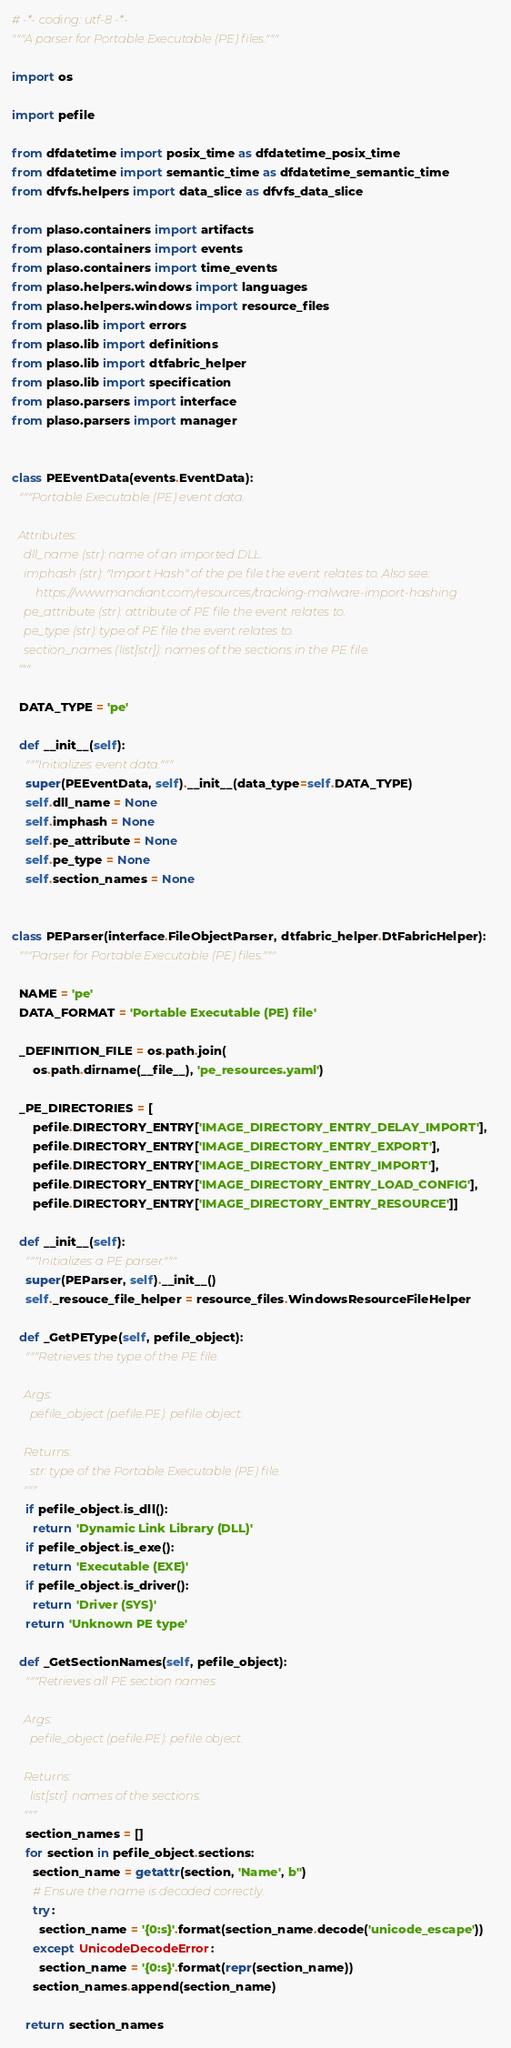Convert code to text. <code><loc_0><loc_0><loc_500><loc_500><_Python_># -*- coding: utf-8 -*-
"""A parser for Portable Executable (PE) files."""

import os

import pefile

from dfdatetime import posix_time as dfdatetime_posix_time
from dfdatetime import semantic_time as dfdatetime_semantic_time
from dfvfs.helpers import data_slice as dfvfs_data_slice

from plaso.containers import artifacts
from plaso.containers import events
from plaso.containers import time_events
from plaso.helpers.windows import languages
from plaso.helpers.windows import resource_files
from plaso.lib import errors
from plaso.lib import definitions
from plaso.lib import dtfabric_helper
from plaso.lib import specification
from plaso.parsers import interface
from plaso.parsers import manager


class PEEventData(events.EventData):
  """Portable Executable (PE) event data.

  Attributes:
    dll_name (str): name of an imported DLL.
    imphash (str): "Import Hash" of the pe file the event relates to. Also see:
        https://www.mandiant.com/resources/tracking-malware-import-hashing
    pe_attribute (str): attribute of PE file the event relates to.
    pe_type (str): type of PE file the event relates to.
    section_names (list[str]): names of the sections in the PE file.
  """

  DATA_TYPE = 'pe'

  def __init__(self):
    """Initializes event data."""
    super(PEEventData, self).__init__(data_type=self.DATA_TYPE)
    self.dll_name = None
    self.imphash = None
    self.pe_attribute = None
    self.pe_type = None
    self.section_names = None


class PEParser(interface.FileObjectParser, dtfabric_helper.DtFabricHelper):
  """Parser for Portable Executable (PE) files."""

  NAME = 'pe'
  DATA_FORMAT = 'Portable Executable (PE) file'

  _DEFINITION_FILE = os.path.join(
      os.path.dirname(__file__), 'pe_resources.yaml')

  _PE_DIRECTORIES = [
      pefile.DIRECTORY_ENTRY['IMAGE_DIRECTORY_ENTRY_DELAY_IMPORT'],
      pefile.DIRECTORY_ENTRY['IMAGE_DIRECTORY_ENTRY_EXPORT'],
      pefile.DIRECTORY_ENTRY['IMAGE_DIRECTORY_ENTRY_IMPORT'],
      pefile.DIRECTORY_ENTRY['IMAGE_DIRECTORY_ENTRY_LOAD_CONFIG'],
      pefile.DIRECTORY_ENTRY['IMAGE_DIRECTORY_ENTRY_RESOURCE']]

  def __init__(self):
    """Initializes a PE parser."""
    super(PEParser, self).__init__()
    self._resouce_file_helper = resource_files.WindowsResourceFileHelper

  def _GetPEType(self, pefile_object):
    """Retrieves the type of the PE file.

    Args:
      pefile_object (pefile.PE): pefile object.

    Returns:
      str: type of the Portable Executable (PE) file.
    """
    if pefile_object.is_dll():
      return 'Dynamic Link Library (DLL)'
    if pefile_object.is_exe():
      return 'Executable (EXE)'
    if pefile_object.is_driver():
      return 'Driver (SYS)'
    return 'Unknown PE type'

  def _GetSectionNames(self, pefile_object):
    """Retrieves all PE section names.

    Args:
      pefile_object (pefile.PE): pefile object.

    Returns:
      list[str]: names of the sections.
    """
    section_names = []
    for section in pefile_object.sections:
      section_name = getattr(section, 'Name', b'')
      # Ensure the name is decoded correctly.
      try:
        section_name = '{0:s}'.format(section_name.decode('unicode_escape'))
      except UnicodeDecodeError:
        section_name = '{0:s}'.format(repr(section_name))
      section_names.append(section_name)

    return section_names
</code> 